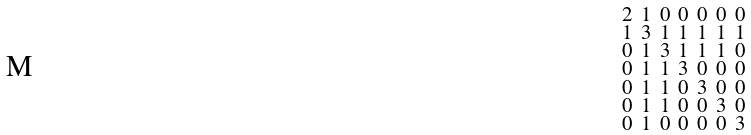Convert formula to latex. <formula><loc_0><loc_0><loc_500><loc_500>\begin{smallmatrix} 2 & 1 & 0 & 0 & 0 & 0 & 0 \\ 1 & 3 & 1 & 1 & 1 & 1 & 1 \\ 0 & 1 & 3 & 1 & 1 & 1 & 0 \\ 0 & 1 & 1 & 3 & 0 & 0 & 0 \\ 0 & 1 & 1 & 0 & 3 & 0 & 0 \\ 0 & 1 & 1 & 0 & 0 & 3 & 0 \\ 0 & 1 & 0 & 0 & 0 & 0 & 3 \end{smallmatrix}</formula> 